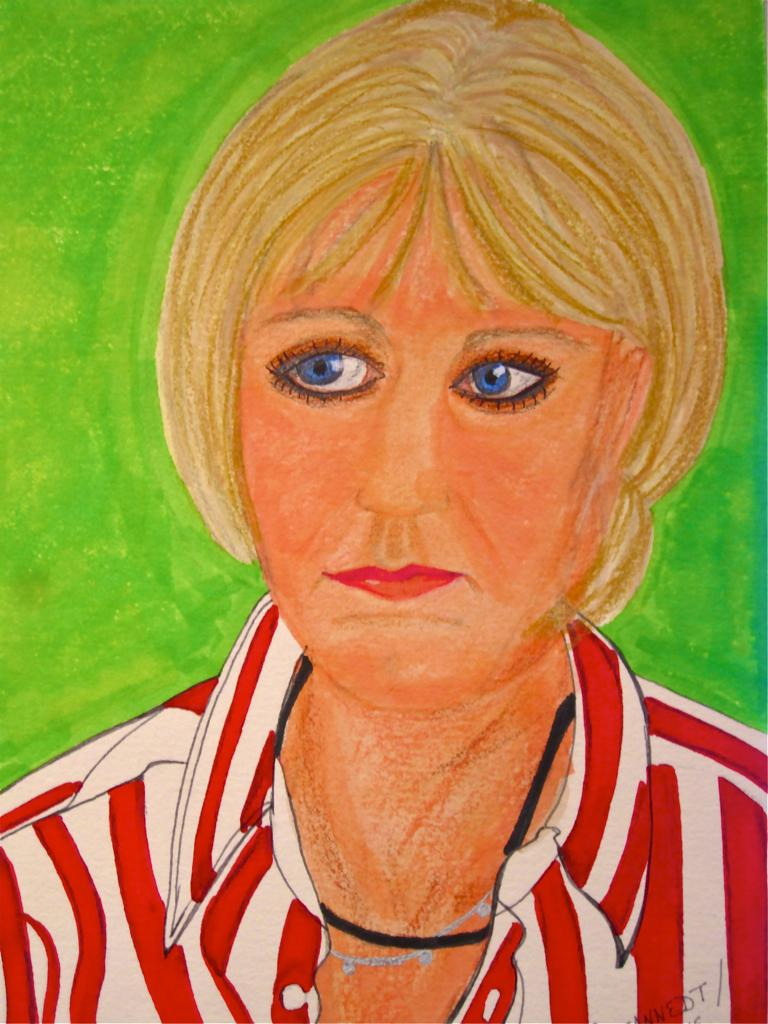What is depicted in the image? There is a drawing of a woman in the image. What color is the background of the drawing? The background of the drawing is green. Where is the duck sitting on the shelf in the image? There is no duck or shelf present in the image; it only features a drawing of a woman with a green background. 